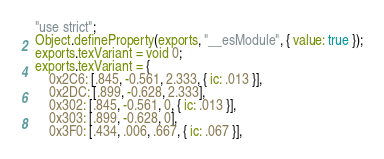<code> <loc_0><loc_0><loc_500><loc_500><_JavaScript_>"use strict";
Object.defineProperty(exports, "__esModule", { value: true });
exports.texVariant = void 0;
exports.texVariant = {
    0x2C6: [.845, -0.561, 2.333, { ic: .013 }],
    0x2DC: [.899, -0.628, 2.333],
    0x302: [.845, -0.561, 0, { ic: .013 }],
    0x303: [.899, -0.628, 0],
    0x3F0: [.434, .006, .667, { ic: .067 }],</code> 